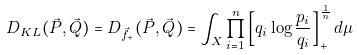Convert formula to latex. <formula><loc_0><loc_0><loc_500><loc_500>D _ { K L } ( \vec { P } , \vec { Q } ) = D _ { \vec { f } _ { + } } ( \vec { P } , \vec { Q } ) = \int _ { X } \prod _ { i = 1 } ^ { n } \left [ q _ { i } \log \frac { p _ { i } } { q _ { i } } \right ] _ { + } ^ { \frac { 1 } { n } } d \mu</formula> 